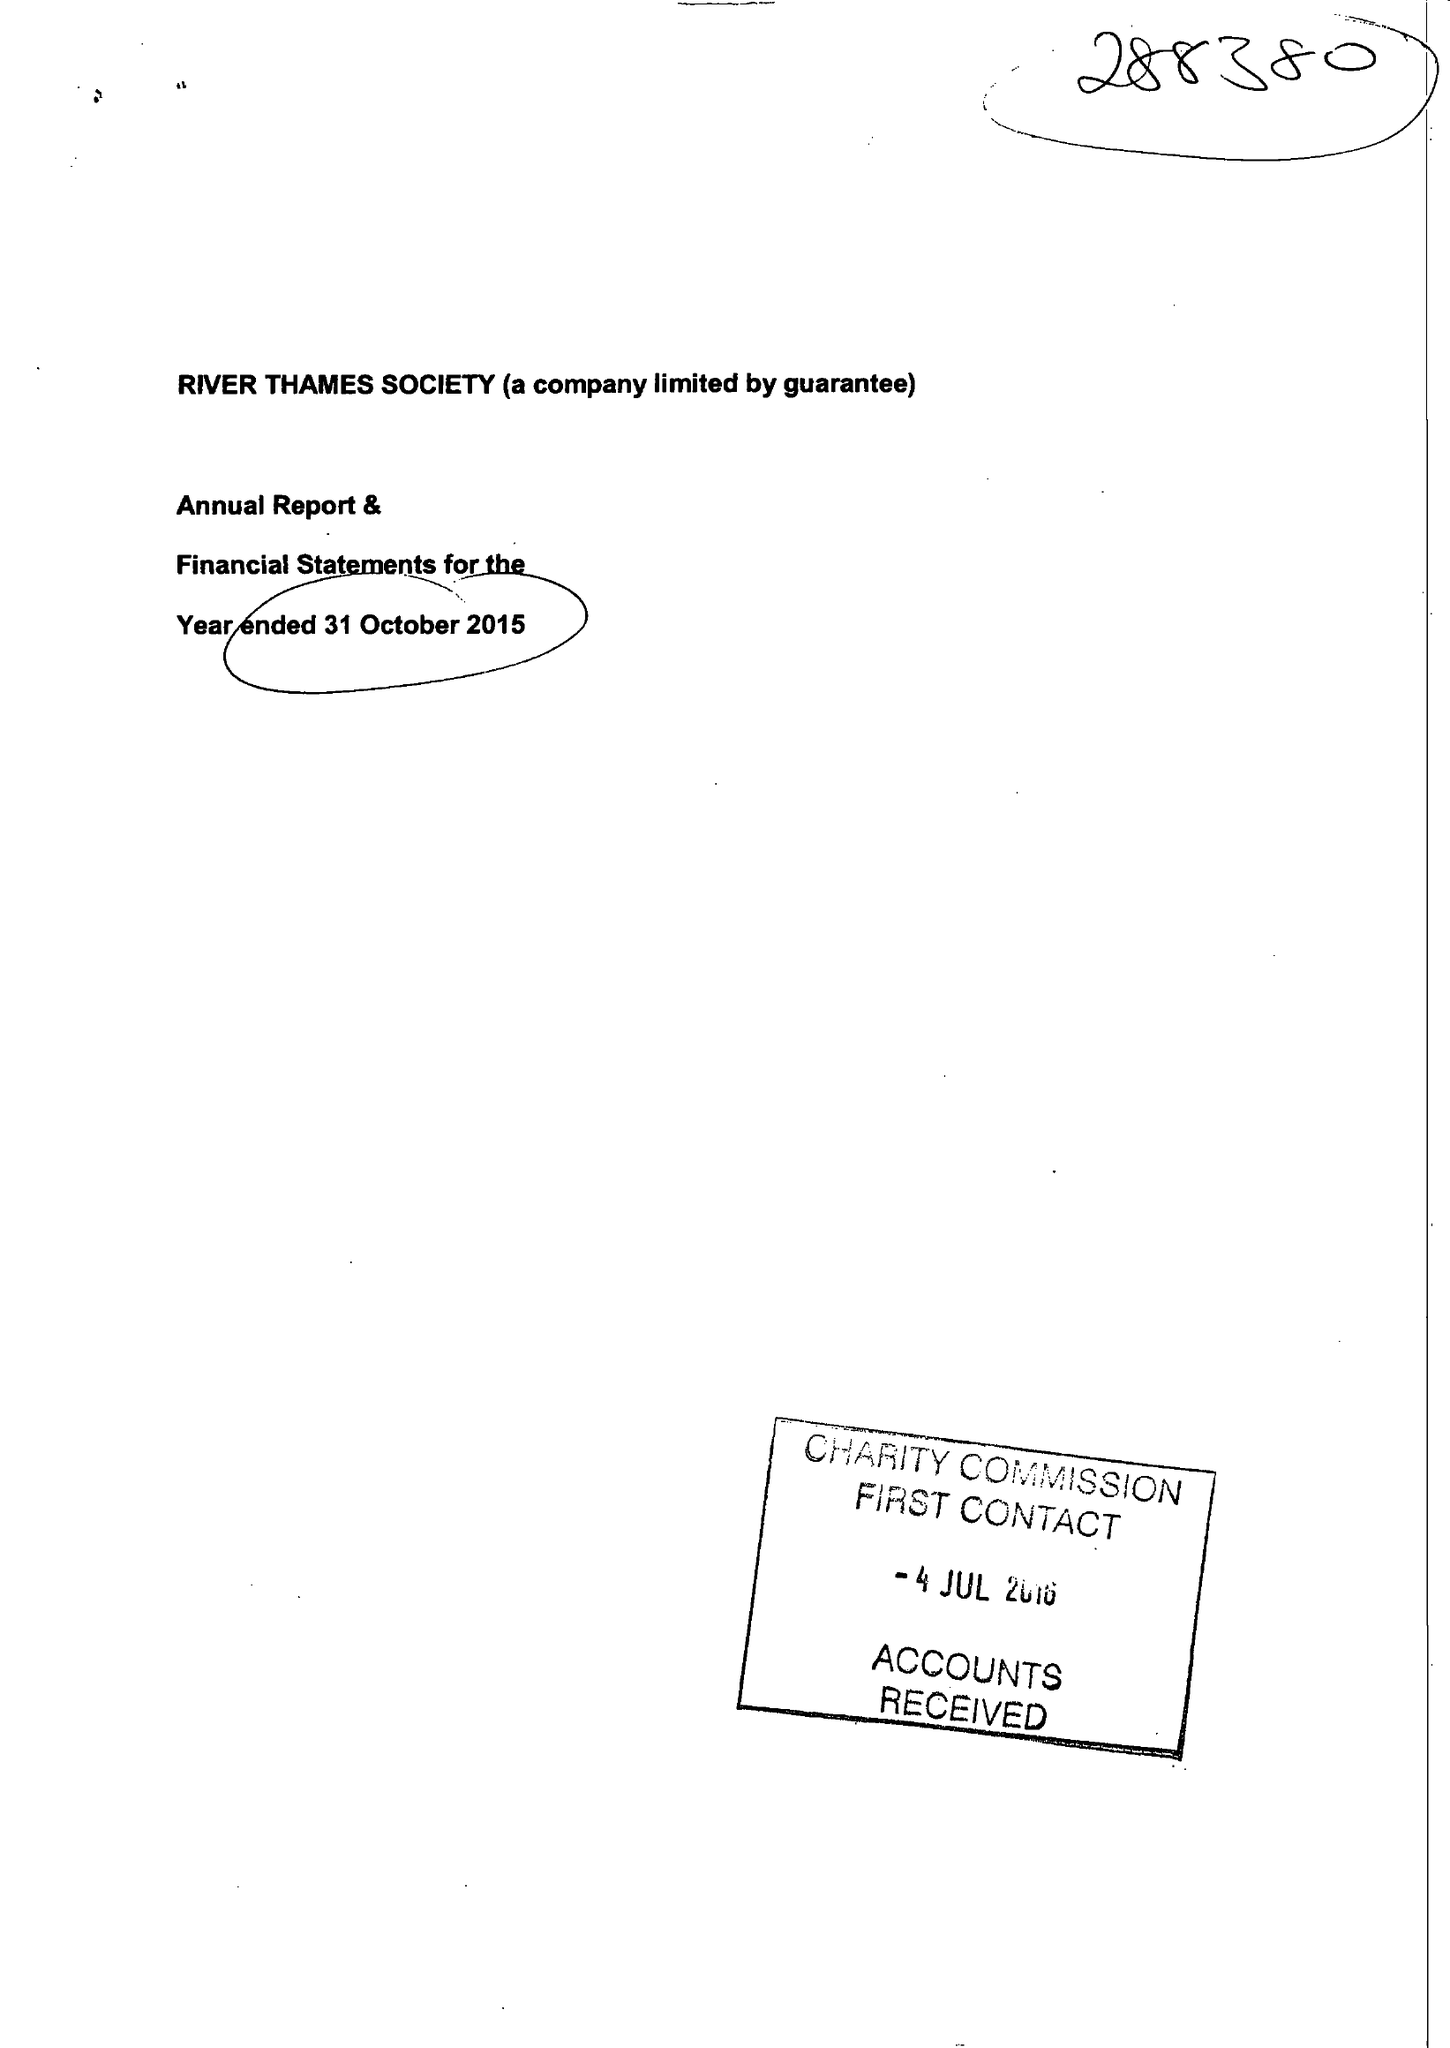What is the value for the income_annually_in_british_pounds?
Answer the question using a single word or phrase. 40251.00 